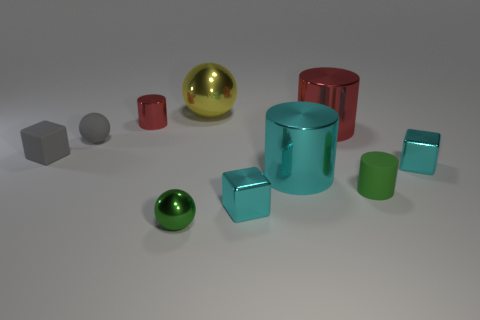What is the gray block made of?
Make the answer very short. Rubber. What is the shape of the tiny rubber thing that is behind the cube left of the tiny gray ball?
Keep it short and to the point. Sphere. What shape is the large shiny thing that is in front of the large red cylinder?
Offer a terse response. Cylinder. How many tiny rubber blocks are the same color as the small matte ball?
Provide a short and direct response. 1. The small metal cylinder is what color?
Provide a short and direct response. Red. What number of big metal things are in front of the red cylinder that is on the right side of the green sphere?
Ensure brevity in your answer.  1. There is a rubber cube; does it have the same size as the metal sphere behind the small red metallic cylinder?
Provide a succinct answer. No. Is the rubber sphere the same size as the yellow shiny thing?
Provide a succinct answer. No. Are there any gray balls of the same size as the green rubber cylinder?
Ensure brevity in your answer.  Yes. There is a small thing behind the gray matte sphere; what material is it?
Provide a short and direct response. Metal. 